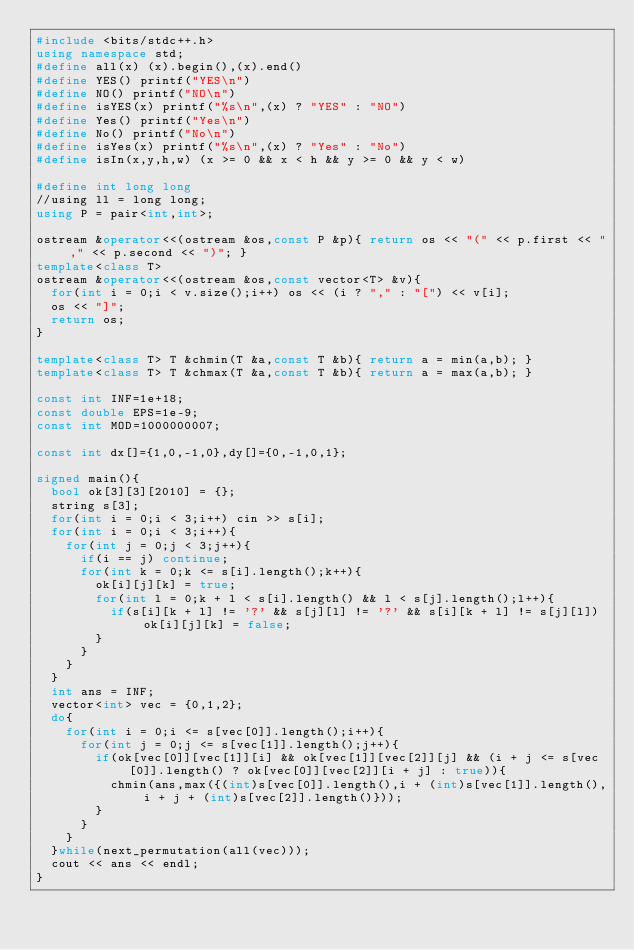Convert code to text. <code><loc_0><loc_0><loc_500><loc_500><_C++_>#include <bits/stdc++.h>
using namespace std;
#define all(x) (x).begin(),(x).end()
#define YES() printf("YES\n")
#define NO() printf("NO\n")
#define isYES(x) printf("%s\n",(x) ? "YES" : "NO")
#define Yes() printf("Yes\n")
#define No() printf("No\n")
#define isYes(x) printf("%s\n",(x) ? "Yes" : "No")
#define isIn(x,y,h,w) (x >= 0 && x < h && y >= 0 && y < w)

#define int long long
//using ll = long long;
using P = pair<int,int>;

ostream &operator<<(ostream &os,const P &p){ return os << "(" << p.first << "," << p.second << ")"; }
template<class T>
ostream &operator<<(ostream &os,const vector<T> &v){
	for(int i = 0;i < v.size();i++) os << (i ? "," : "[") << v[i];
	os << "]";
	return os;
}

template<class T> T &chmin(T &a,const T &b){ return a = min(a,b); }
template<class T> T &chmax(T &a,const T &b){ return a = max(a,b); }

const int INF=1e+18;
const double EPS=1e-9;
const int MOD=1000000007;

const int dx[]={1,0,-1,0},dy[]={0,-1,0,1};

signed main(){
	bool ok[3][3][2010] = {};
	string s[3];
	for(int i = 0;i < 3;i++) cin >> s[i];
	for(int i = 0;i < 3;i++){
		for(int j = 0;j < 3;j++){
			if(i == j) continue;
			for(int k = 0;k <= s[i].length();k++){
				ok[i][j][k] = true;
				for(int l = 0;k + l < s[i].length() && l < s[j].length();l++){
					if(s[i][k + l] != '?' && s[j][l] != '?' && s[i][k + l] != s[j][l]) ok[i][j][k] = false;
				}
			}
		}
	}
	int ans = INF;
	vector<int> vec = {0,1,2};
	do{
		for(int i = 0;i <= s[vec[0]].length();i++){
			for(int j = 0;j <= s[vec[1]].length();j++){
				if(ok[vec[0]][vec[1]][i] && ok[vec[1]][vec[2]][j] && (i + j <= s[vec[0]].length() ? ok[vec[0]][vec[2]][i + j] : true)){
					chmin(ans,max({(int)s[vec[0]].length(),i + (int)s[vec[1]].length(),i + j + (int)s[vec[2]].length()}));
				}
			}
		}
	}while(next_permutation(all(vec)));
	cout << ans << endl;
}
</code> 